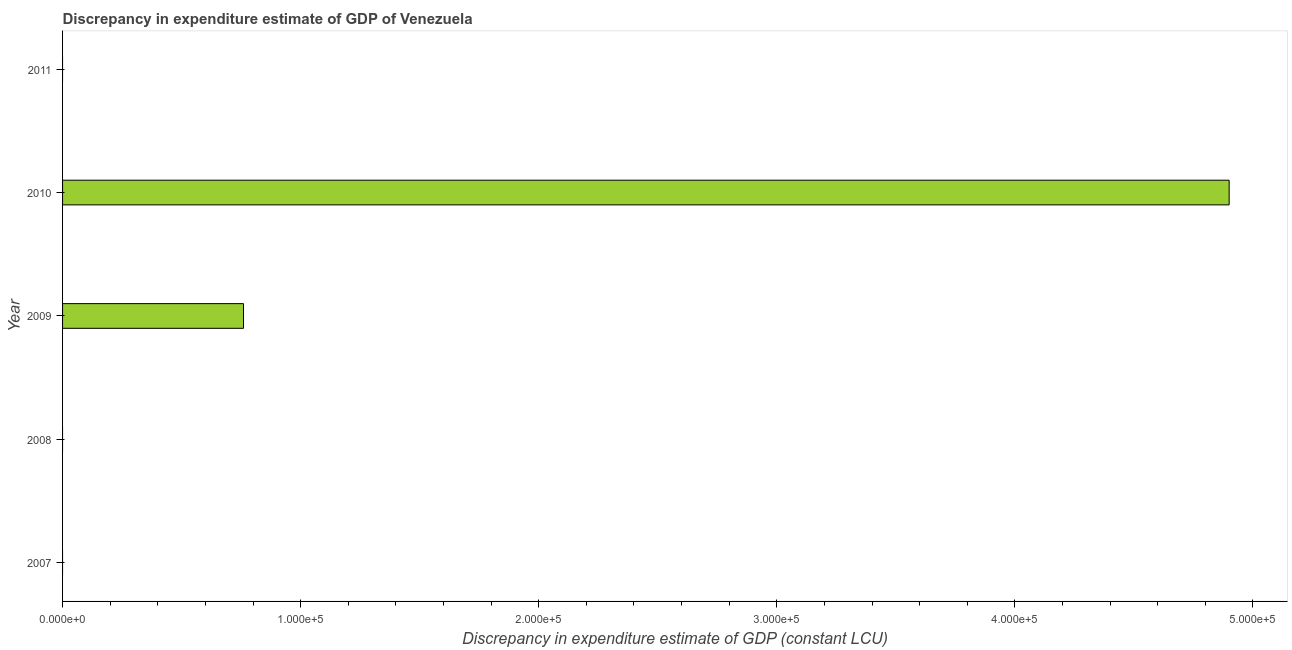Does the graph contain any zero values?
Your answer should be compact. Yes. What is the title of the graph?
Keep it short and to the point. Discrepancy in expenditure estimate of GDP of Venezuela. What is the label or title of the X-axis?
Your response must be concise. Discrepancy in expenditure estimate of GDP (constant LCU). What is the discrepancy in expenditure estimate of gdp in 2010?
Make the answer very short. 4.90e+05. Across all years, what is the maximum discrepancy in expenditure estimate of gdp?
Offer a terse response. 4.90e+05. Across all years, what is the minimum discrepancy in expenditure estimate of gdp?
Your answer should be very brief. 0. What is the sum of the discrepancy in expenditure estimate of gdp?
Offer a very short reply. 5.66e+05. What is the difference between the discrepancy in expenditure estimate of gdp in 2009 and 2010?
Your response must be concise. -4.14e+05. What is the average discrepancy in expenditure estimate of gdp per year?
Your answer should be very brief. 1.13e+05. What is the median discrepancy in expenditure estimate of gdp?
Give a very brief answer. 0. Is the discrepancy in expenditure estimate of gdp in 2009 less than that in 2010?
Offer a very short reply. Yes. Is the difference between the discrepancy in expenditure estimate of gdp in 2009 and 2010 greater than the difference between any two years?
Offer a very short reply. No. What is the difference between the highest and the lowest discrepancy in expenditure estimate of gdp?
Your answer should be very brief. 4.90e+05. In how many years, is the discrepancy in expenditure estimate of gdp greater than the average discrepancy in expenditure estimate of gdp taken over all years?
Ensure brevity in your answer.  1. How many bars are there?
Make the answer very short. 2. How many years are there in the graph?
Your answer should be very brief. 5. What is the Discrepancy in expenditure estimate of GDP (constant LCU) of 2007?
Provide a succinct answer. 0. What is the Discrepancy in expenditure estimate of GDP (constant LCU) of 2009?
Offer a terse response. 7.60e+04. What is the Discrepancy in expenditure estimate of GDP (constant LCU) of 2010?
Make the answer very short. 4.90e+05. What is the difference between the Discrepancy in expenditure estimate of GDP (constant LCU) in 2009 and 2010?
Give a very brief answer. -4.14e+05. What is the ratio of the Discrepancy in expenditure estimate of GDP (constant LCU) in 2009 to that in 2010?
Your answer should be very brief. 0.15. 